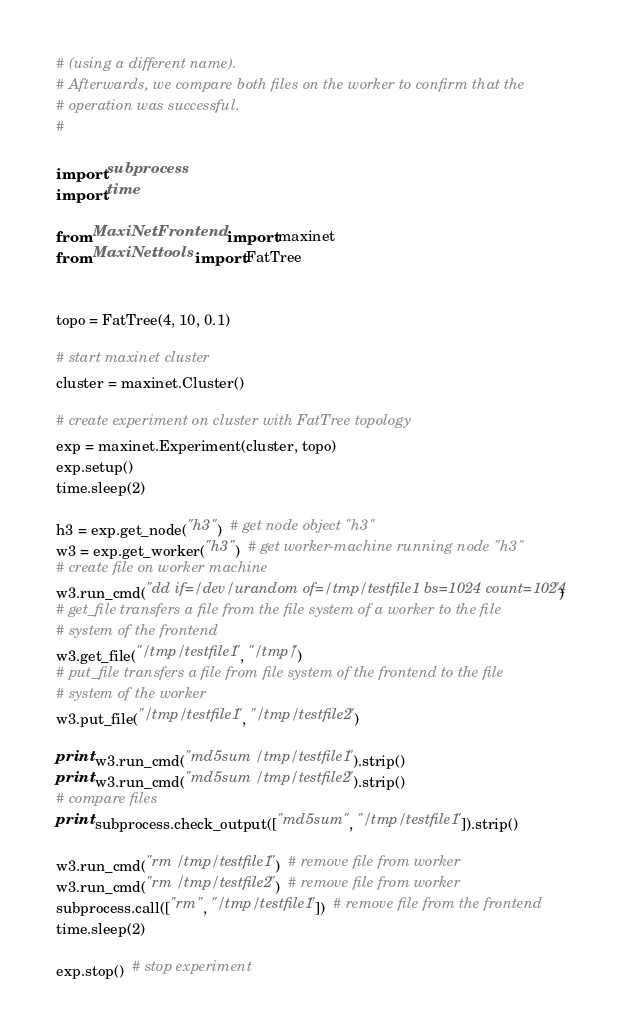Convert code to text. <code><loc_0><loc_0><loc_500><loc_500><_Python_># (using a different name).
# Afterwards, we compare both files on the worker to confirm that the
# operation was successful.
#

import subprocess
import time

from MaxiNet.Frontend import maxinet
from MaxiNet.tools import FatTree


topo = FatTree(4, 10, 0.1)

# start maxinet cluster
cluster = maxinet.Cluster()

# create experiment on cluster with FatTree topology
exp = maxinet.Experiment(cluster, topo)
exp.setup()
time.sleep(2)

h3 = exp.get_node("h3")  # get node object "h3"
w3 = exp.get_worker("h3")  # get worker-machine running node "h3"
# create file on worker machine
w3.run_cmd("dd if=/dev/urandom of=/tmp/testfile1 bs=1024 count=1024")
# get_file transfers a file from the file system of a worker to the file
# system of the frontend
w3.get_file("/tmp/testfile1", "/tmp/")
# put_file transfers a file from file system of the frontend to the file
# system of the worker
w3.put_file("/tmp/testfile1", "/tmp/testfile2")

print w3.run_cmd("md5sum /tmp/testfile1").strip()
print w3.run_cmd("md5sum /tmp/testfile2").strip()
# compare files
print subprocess.check_output(["md5sum", "/tmp/testfile1"]).strip()

w3.run_cmd("rm /tmp/testfile1")  # remove file from worker
w3.run_cmd("rm /tmp/testfile2")  # remove file from worker
subprocess.call(["rm", "/tmp/testfile1"])  # remove file from the frontend
time.sleep(2)

exp.stop()  # stop experiment
</code> 